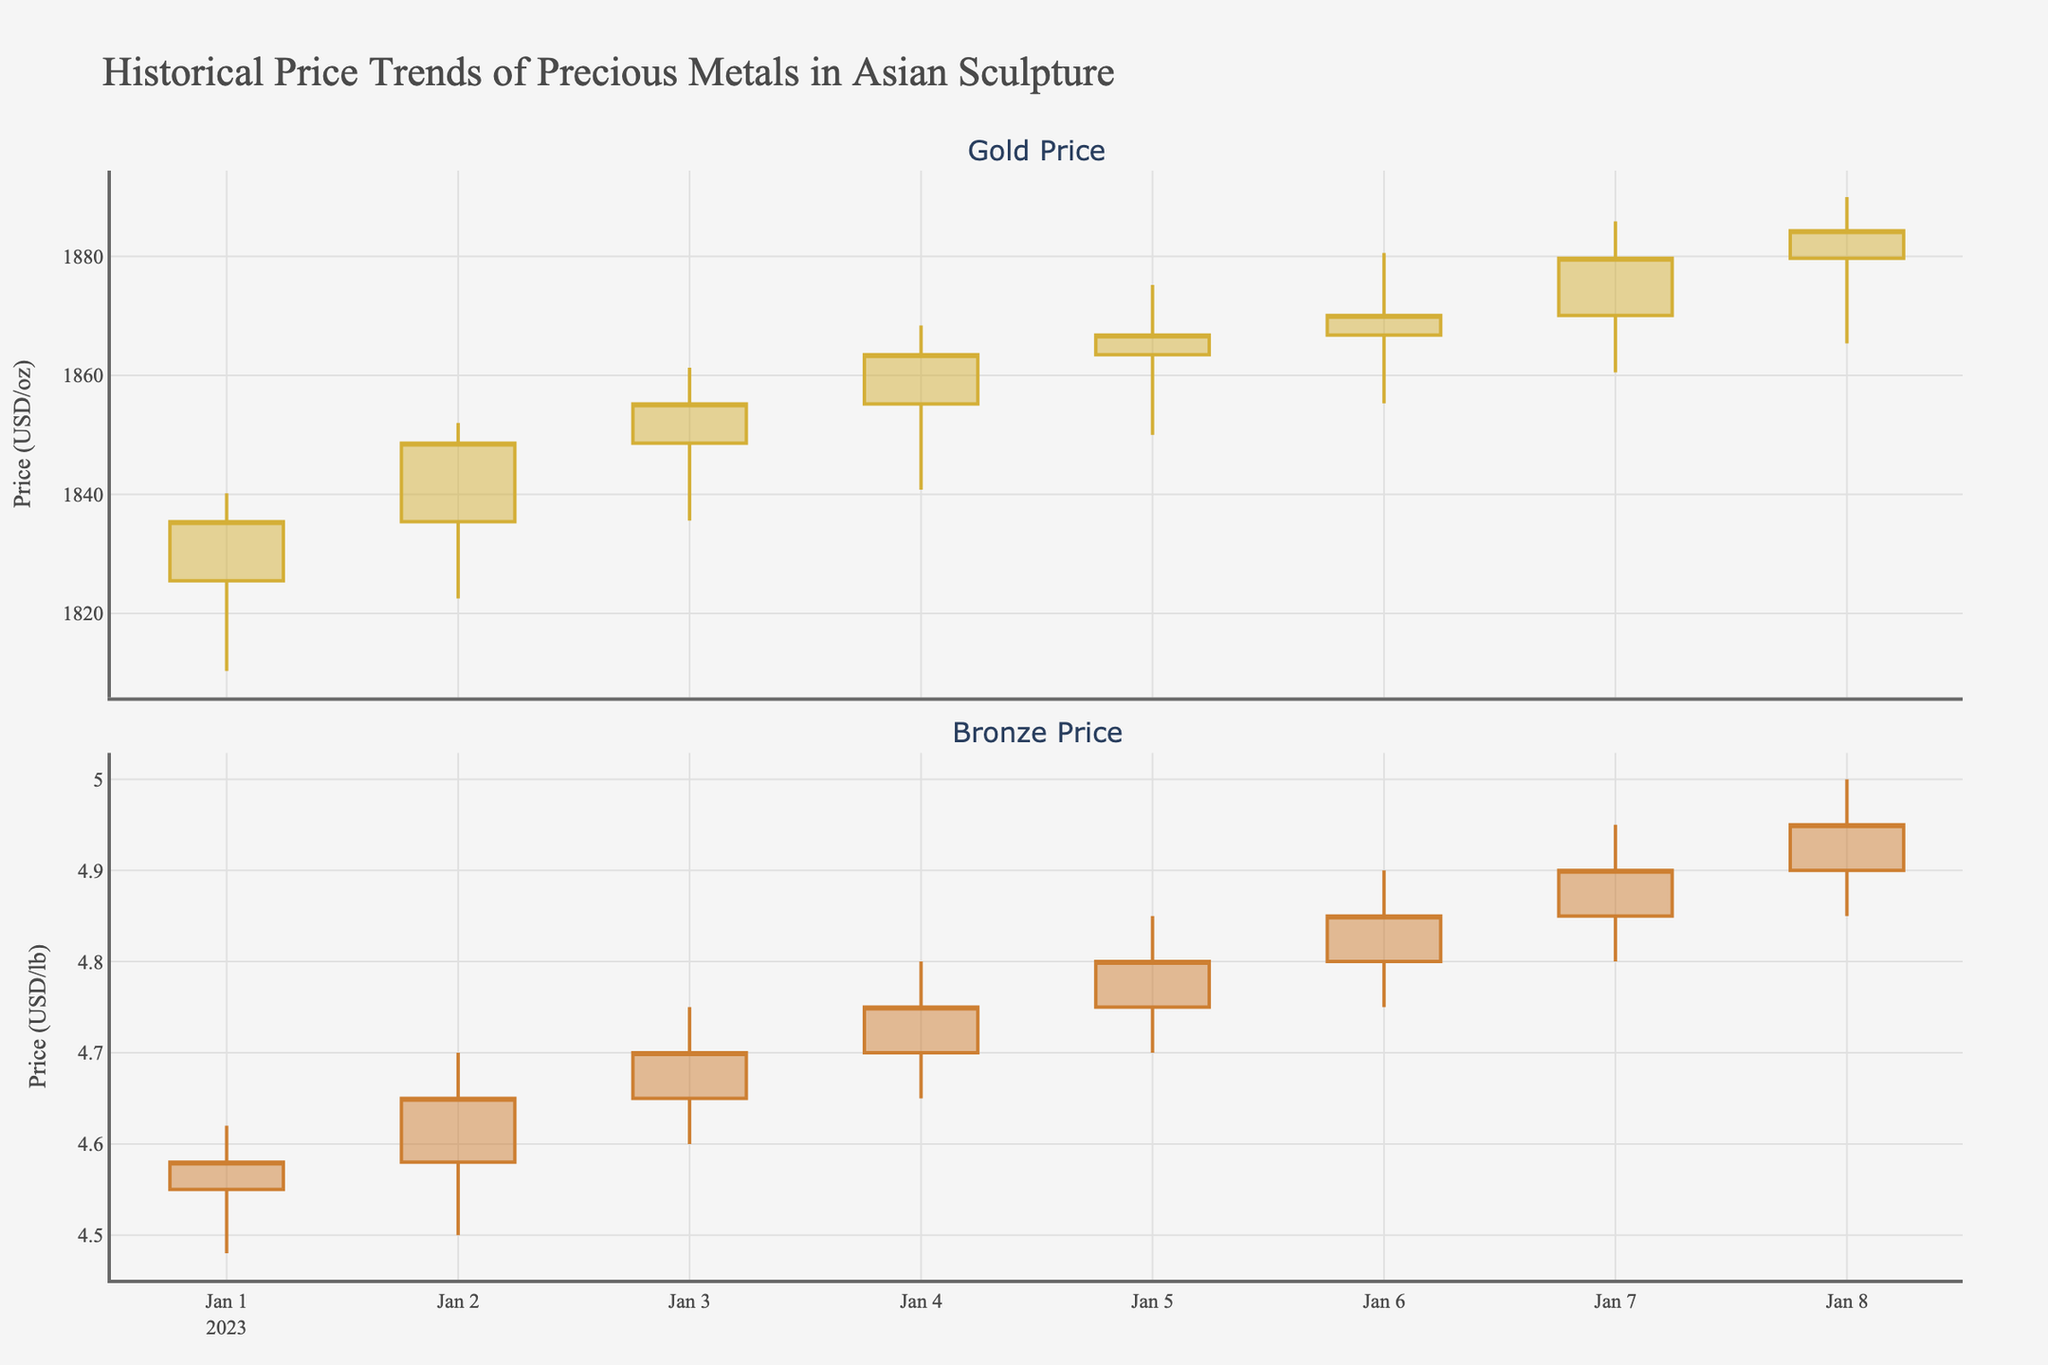What's the highest price of Gold during the given dates? The highest price of Gold can be found by looking at the "High" column for Gold data, and checking for the maximum value listed. In the figure, the highest price Gold reached is $1890.00.
Answer: $1890.00 On which date did Bronze close at its highest price? The highest closing price for Bronze can be identified by looking at the candlestick closing prices for Bronze data in the plot. Bronze closed at its highest price of $4.95 on January 8, 2023.
Answer: January 8, 2023 Which metal shows a more significant price increase over the given period? To determine which metal shows a more significant price increase, we compare the difference in the closing prices from the first to the last date for each metal. Gold increased from $1835.40 to $1884.30, a difference of $48.90. Bronze increased from $4.58 to $4.95, a difference of $0.37. Since Gold's price change ($48.90) is more significant than Bronze's ($0.37), Gold shows a more significant price increase.
Answer: Gold How often did the price of Gold close higher than it opened during the period? To answer this, we need to count the days when the closing price is higher than the opening price for Gold. By checking the candlestick plots for Gold, there are 6 days where the closing price is higher than the opening price (i.e., January 2, 3, 4, 5, 6, and 8).
Answer: 6 days What was the average closing price of Bronze during the given period? To find the average closing price of Bronze, sum all closing prices and divide by the number of days. The closing prices are $4.58, $4.65, $4.70, $4.75, $4.80, $4.85, $4.90, $4.95. Therefore, (4.58 + 4.65 + 4.70 + 4.75 + 4.80 + 4.85 + 4.90 + 4.95) / 8 = 37.18 / 8 = 4.65
Answer: $4.65 Which day saw the highest trading volume for Gold? The trading volume can be determined from the "Volume" data. The highest trading volume for Gold is 11,000 units, which occurred on January 1, 2023.
Answer: January 1, 2023 Compare the price volatility of Gold and Bronze over the given period. Which metal showed higher relative volatility? Volatility can be assessed by the range (High - Low) for each day. Gold ranges are 29.9, 29.5, 25.7, 27.6, 25.2, 25.3, 25.4, 24.6. Bronze ranges are 0.14, 0.20, 0.15, 0.15, 0.15, 0.15, 0.15, 0.15. Average ranges are 26 for Gold and 0.16 for Bronze. Adjusted for price levels, average Gold volatility is 26/1864.15 ≈ 1.39%, and average Bronze volatility is 0.16/4.725 ≈ 3.39%. Bronze shows higher relative volatility.
Answer: Bronze 